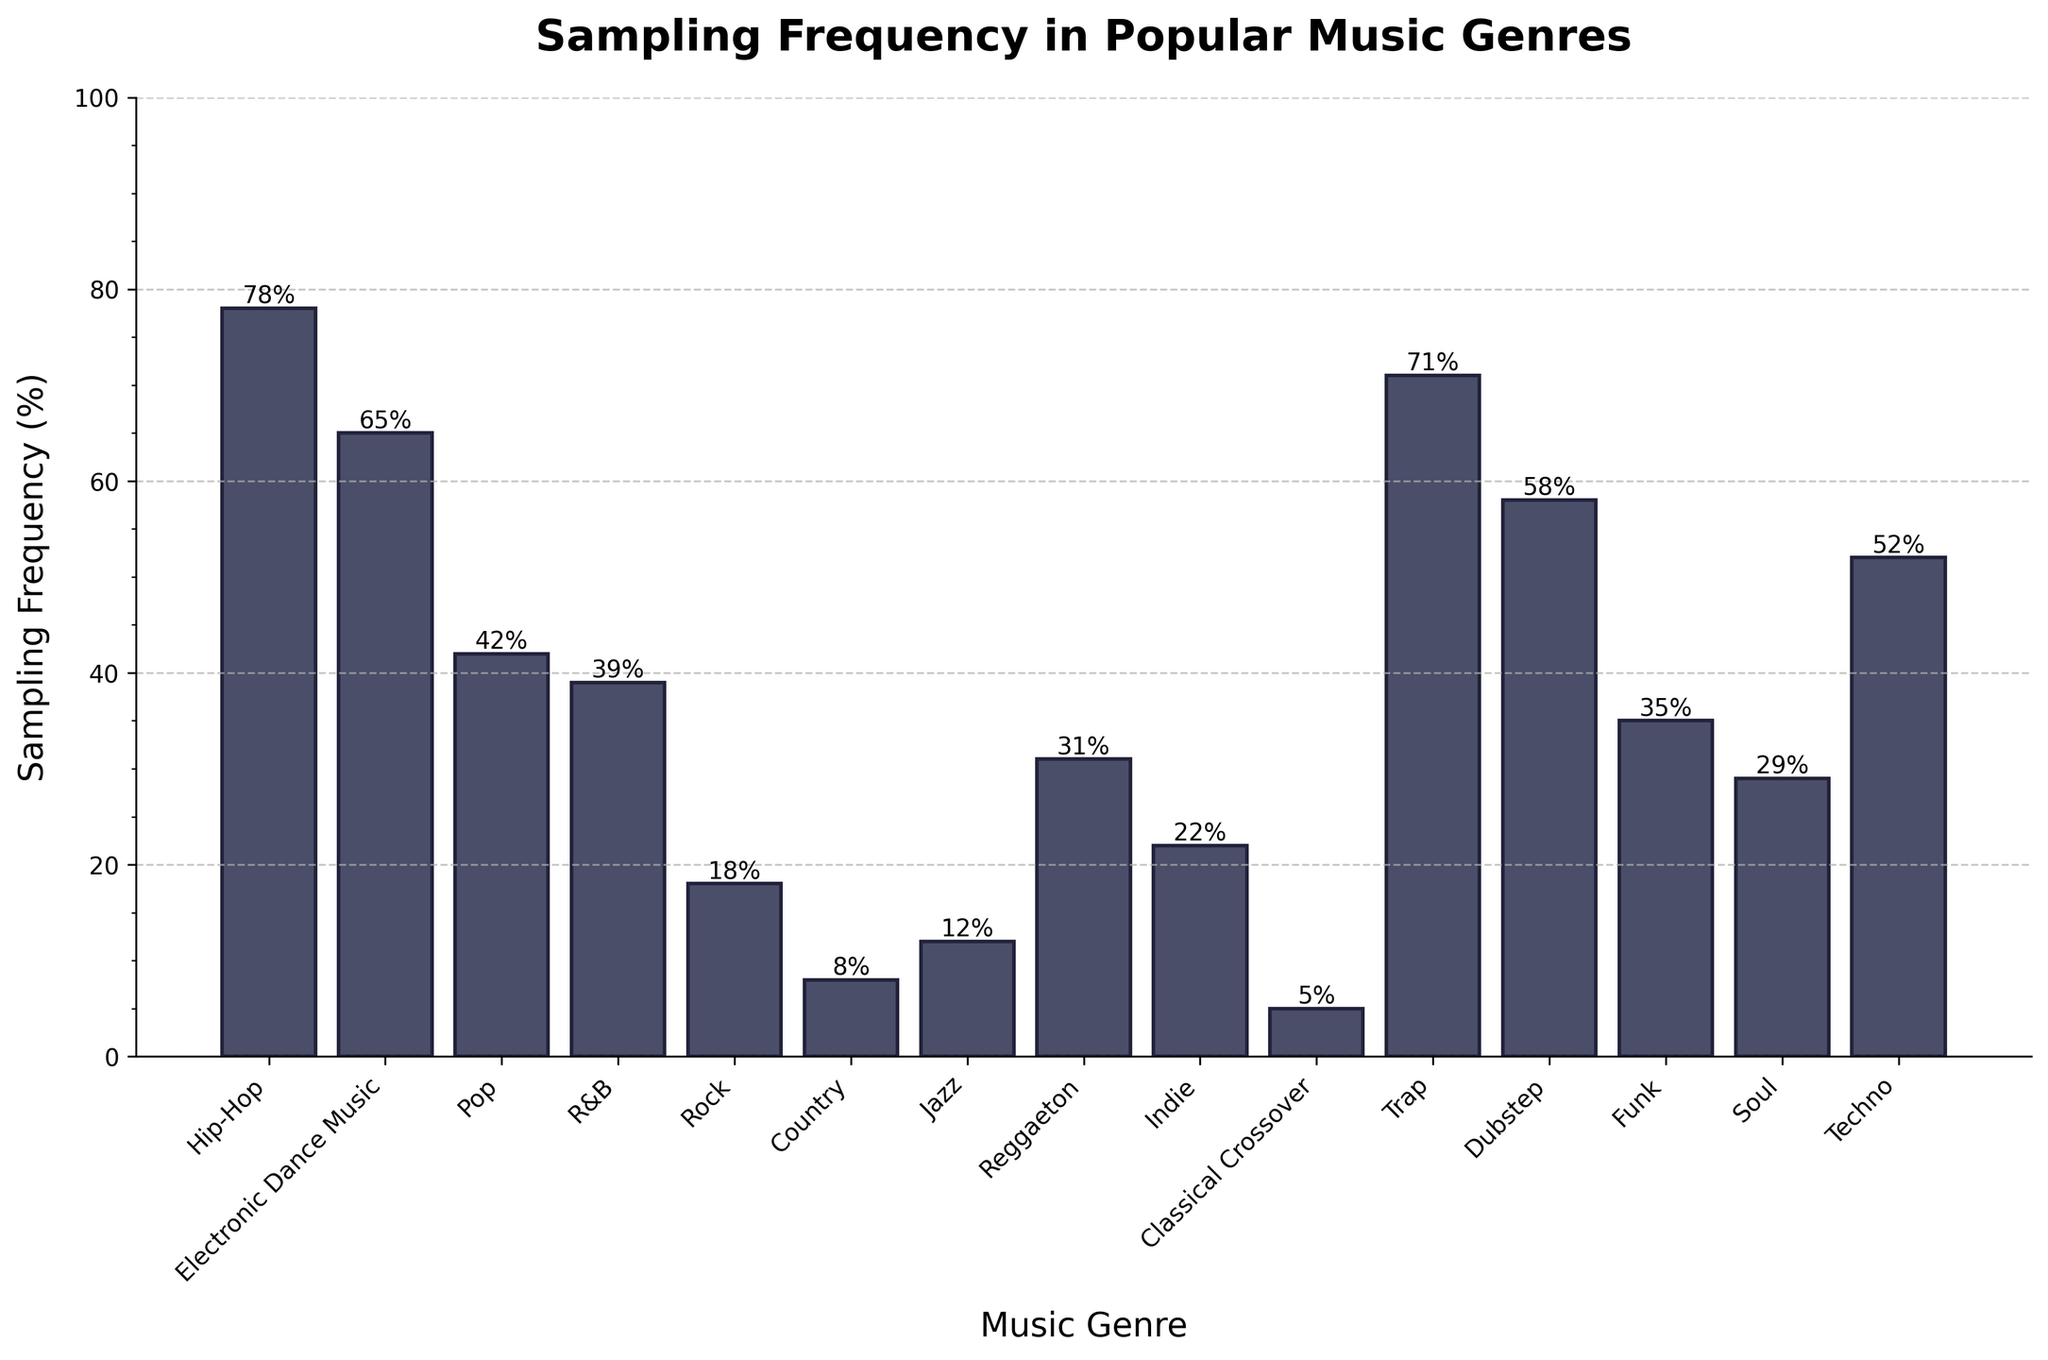What genre has the highest sampling frequency? By looking at the height of the bars in the chart, it is clear that Hip-Hop has the highest sampling frequency bar, which reaches up to 78%.
Answer: Hip-Hop Which two genres have nearly similar sampling frequencies? By comparing the heights of the bars, Trap and Hip-Hop have similar frequencies, although Hip-Hop is slightly higher at 78% compared to Trap at 71%. Similarly, R&B and Reggaeton have close frequencies of 39% and 31%.
Answer: Trap and Hip-Hop, R&B and Reggaeton What is the combined sampling frequency of Rock, Country, and Jazz? The heights of the bars for Rock, Country, and Jazz are respectively 18%, 8%, and 12%. Summing these values gives 18 + 8 + 12 = 38%.
Answer: 38% Which genre has a sampling frequency greater than 50% but less than 60%? Examining the bars, Dubstep and Techno have frequencies within this range. Dubstep is 58% and Techno 52%.
Answer: Dubstep and Techno What is the difference in sampling frequency between the genre with the highest value and the genre with the lowest value? The highest sampling frequency is for Hip-Hop at 78% and the lowest is Classical Crossover at 5%. The difference is 78% - 5% = 73%.
Answer: 73% Which genre has the lowest sampling frequency? Based on the shortest bar in the chart, Classical Crossover has the lowest sampling frequency of 5%.
Answer: Classical Crossover What is the average sampling frequency of the genres listed? Summing up the sampling frequencies for all genres: 78 + 65 + 42 + 39 + 18 + 8 + 12 + 31 + 22 + 5 + 71 + 58 + 35 + 29 + 52 = 565. There are 15 genres, so the average is 565/15 = 37.67%.
Answer: 37.67% What genres have a sampling frequency between 30% and 40%? The bars for genres with these sampling frequencies are R&B at 39%, Reggaeton at 31%, and Soul at 29%.
Answer: R&B and Reggaeton How many genres have a sampling frequency above 50%? By counting the bars above the 50% line, there are five genres: Hip-Hop, Trap, EDM, Dubstep, and Techno.
Answer: 5 genres 